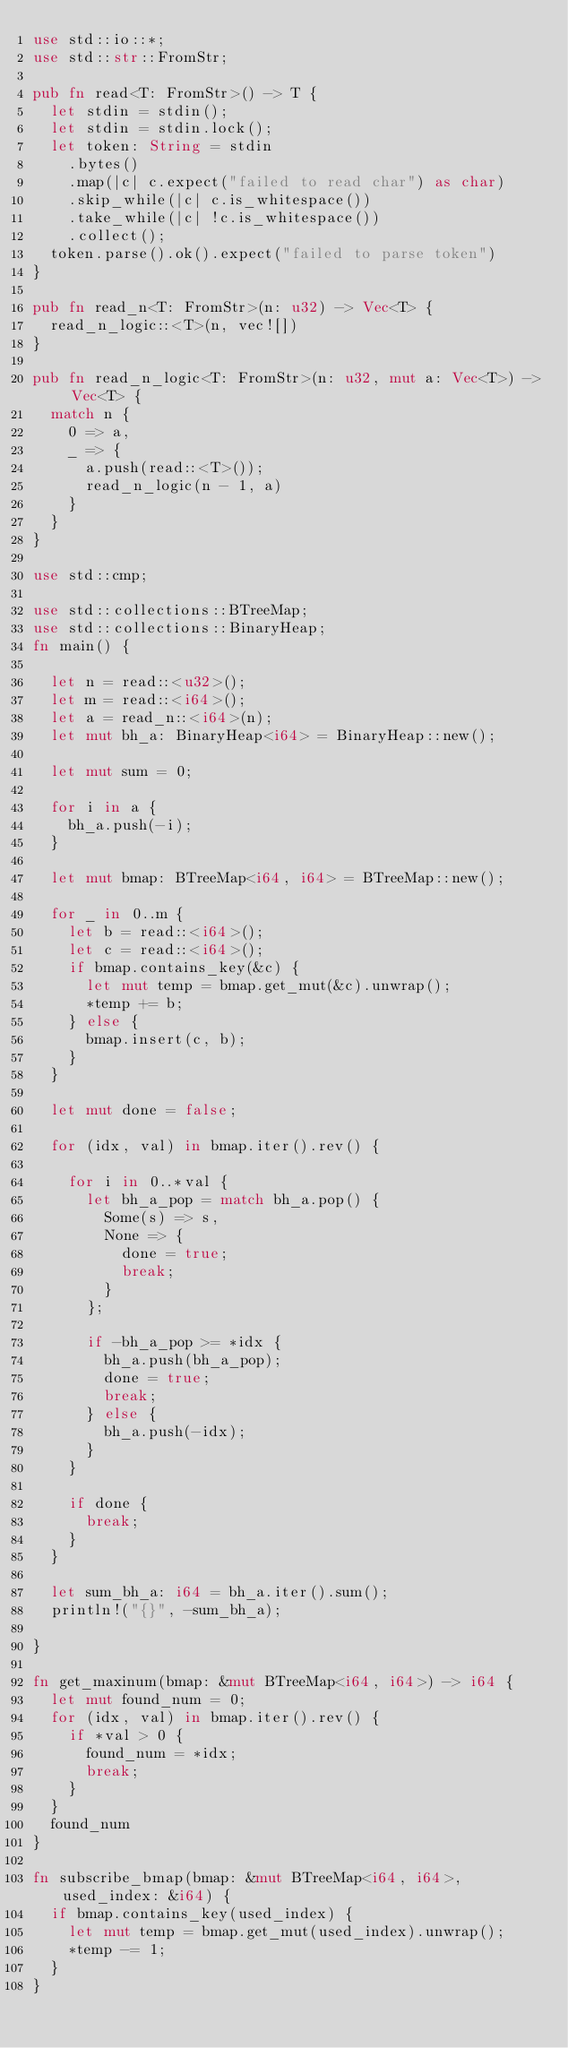Convert code to text. <code><loc_0><loc_0><loc_500><loc_500><_Rust_>use std::io::*;
use std::str::FromStr;

pub fn read<T: FromStr>() -> T {
  let stdin = stdin();
  let stdin = stdin.lock();
  let token: String = stdin
    .bytes()
    .map(|c| c.expect("failed to read char") as char)
    .skip_while(|c| c.is_whitespace())
    .take_while(|c| !c.is_whitespace())
    .collect();
  token.parse().ok().expect("failed to parse token")
}

pub fn read_n<T: FromStr>(n: u32) -> Vec<T> {
  read_n_logic::<T>(n, vec![])
}

pub fn read_n_logic<T: FromStr>(n: u32, mut a: Vec<T>) -> Vec<T> {
  match n {
    0 => a,
    _ => {
      a.push(read::<T>());
      read_n_logic(n - 1, a)
    }
  }
}

use std::cmp;

use std::collections::BTreeMap;
use std::collections::BinaryHeap;
fn main() {

  let n = read::<u32>();
  let m = read::<i64>();
  let a = read_n::<i64>(n);
  let mut bh_a: BinaryHeap<i64> = BinaryHeap::new();

  let mut sum = 0;

  for i in a {
    bh_a.push(-i);
  }

  let mut bmap: BTreeMap<i64, i64> = BTreeMap::new();

  for _ in 0..m {
    let b = read::<i64>();
    let c = read::<i64>();
    if bmap.contains_key(&c) {
      let mut temp = bmap.get_mut(&c).unwrap();
      *temp += b;
    } else {
      bmap.insert(c, b);
    }
  }

  let mut done = false;

  for (idx, val) in bmap.iter().rev() {

    for i in 0..*val {
      let bh_a_pop = match bh_a.pop() {
        Some(s) => s,
        None => {
          done = true;
          break;
        }
      };

      if -bh_a_pop >= *idx {
        bh_a.push(bh_a_pop);
        done = true;
        break;
      } else {
        bh_a.push(-idx);
      }
    }

    if done {
      break;
    }
  }

  let sum_bh_a: i64 = bh_a.iter().sum();
  println!("{}", -sum_bh_a);

}

fn get_maxinum(bmap: &mut BTreeMap<i64, i64>) -> i64 {
  let mut found_num = 0;
  for (idx, val) in bmap.iter().rev() {
    if *val > 0 {
      found_num = *idx;
      break;
    }
  }
  found_num
}

fn subscribe_bmap(bmap: &mut BTreeMap<i64, i64>, used_index: &i64) {
  if bmap.contains_key(used_index) {
    let mut temp = bmap.get_mut(used_index).unwrap();
    *temp -= 1;
  }
}
</code> 